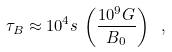<formula> <loc_0><loc_0><loc_500><loc_500>\tau _ { B } \approx 1 0 ^ { 4 } s \, \left ( \frac { 1 0 ^ { 9 } G } { B _ { 0 } } \right ) \ ,</formula> 